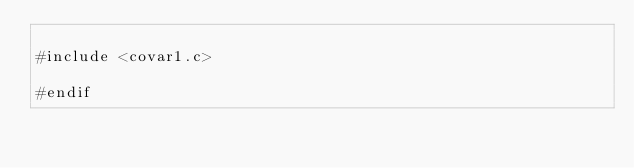Convert code to text. <code><loc_0><loc_0><loc_500><loc_500><_Cuda_>
#include <covar1.c>

#endif
</code> 